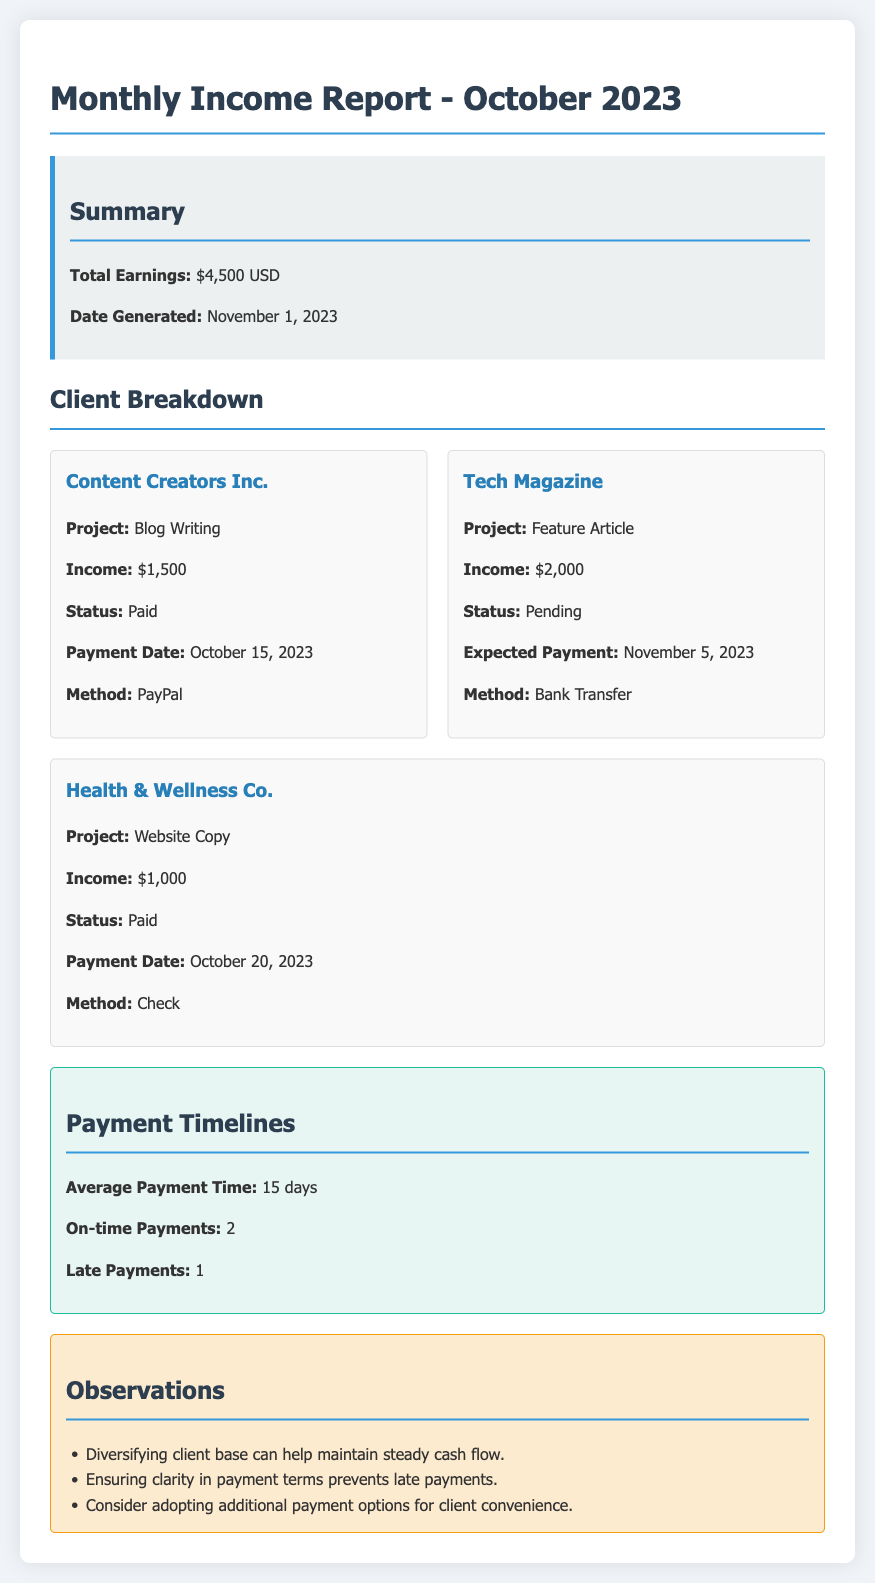What is the total earnings for October 2023? The total earnings is stated in the summary section of the document, which is $4,500 USD.
Answer: $4,500 USD What is the project associated with Tech Magazine? The document specifies that the project for Tech Magazine is a Feature Article.
Answer: Feature Article When was the payment from Content Creators Inc. made? The document notes the payment date for Content Creators Inc. as October 15, 2023.
Answer: October 15, 2023 How many on-time payments were recorded? The payment timelines section indicates that there were 2 on-time payments.
Answer: 2 What is the expected payment date for Tech Magazine? The document indicates that the expected payment date for Tech Magazine is November 5, 2023.
Answer: November 5, 2023 What payment method was used for Health & Wellness Co.? The document lists the payment method for Health & Wellness Co. as Check.
Answer: Check What observation suggests improving cash flow? One observation in the document mentions that diversifying client base can help maintain steady cash flow.
Answer: Diversifying client base What is the average payment time reported? The average payment time is highlighted in the payment timelines section as 15 days.
Answer: 15 days What is the status of the payment for Health & Wellness Co.? The document states that the payment status for Health & Wellness Co. is Paid.
Answer: Paid 